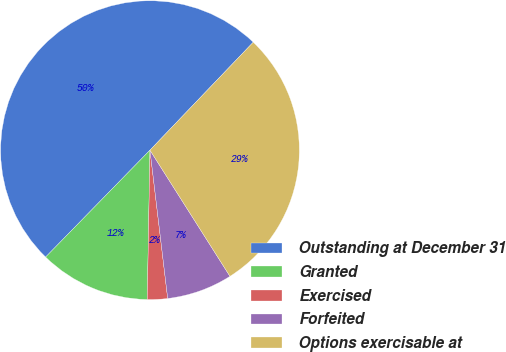<chart> <loc_0><loc_0><loc_500><loc_500><pie_chart><fcel>Outstanding at December 31<fcel>Granted<fcel>Exercised<fcel>Forfeited<fcel>Options exercisable at<nl><fcel>49.84%<fcel>12.02%<fcel>2.18%<fcel>7.1%<fcel>28.86%<nl></chart> 